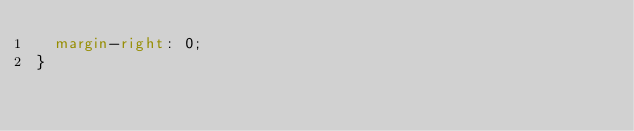<code> <loc_0><loc_0><loc_500><loc_500><_CSS_> 	margin-right: 0;
}
</code> 